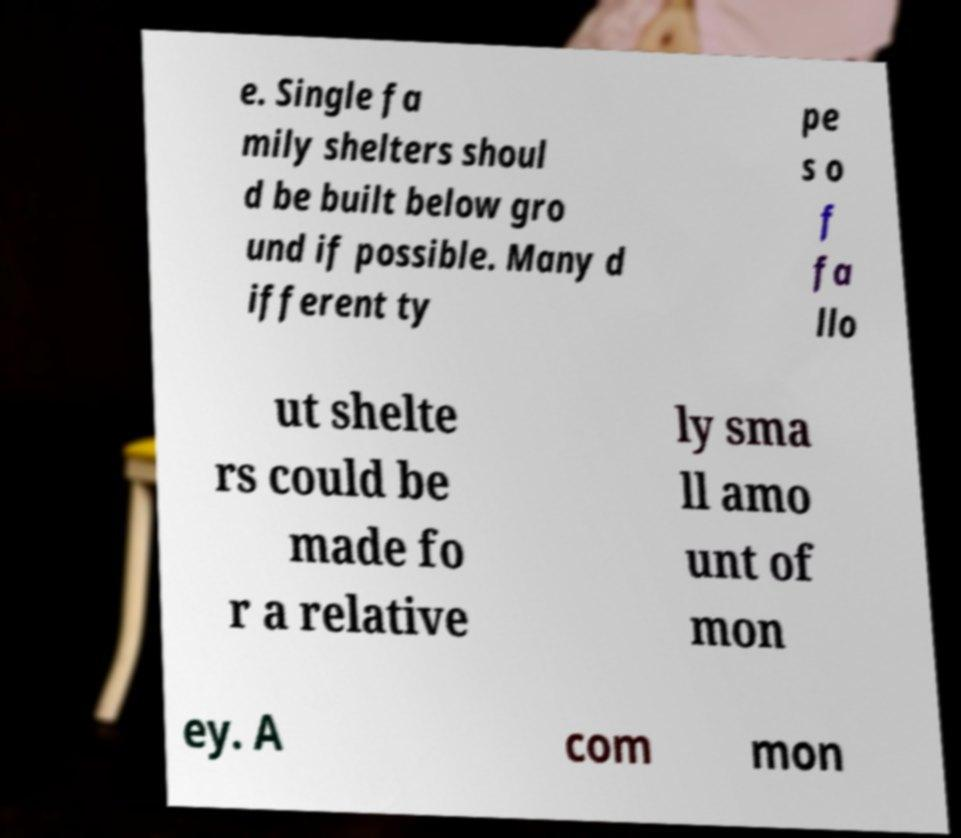I need the written content from this picture converted into text. Can you do that? e. Single fa mily shelters shoul d be built below gro und if possible. Many d ifferent ty pe s o f fa llo ut shelte rs could be made fo r a relative ly sma ll amo unt of mon ey. A com mon 